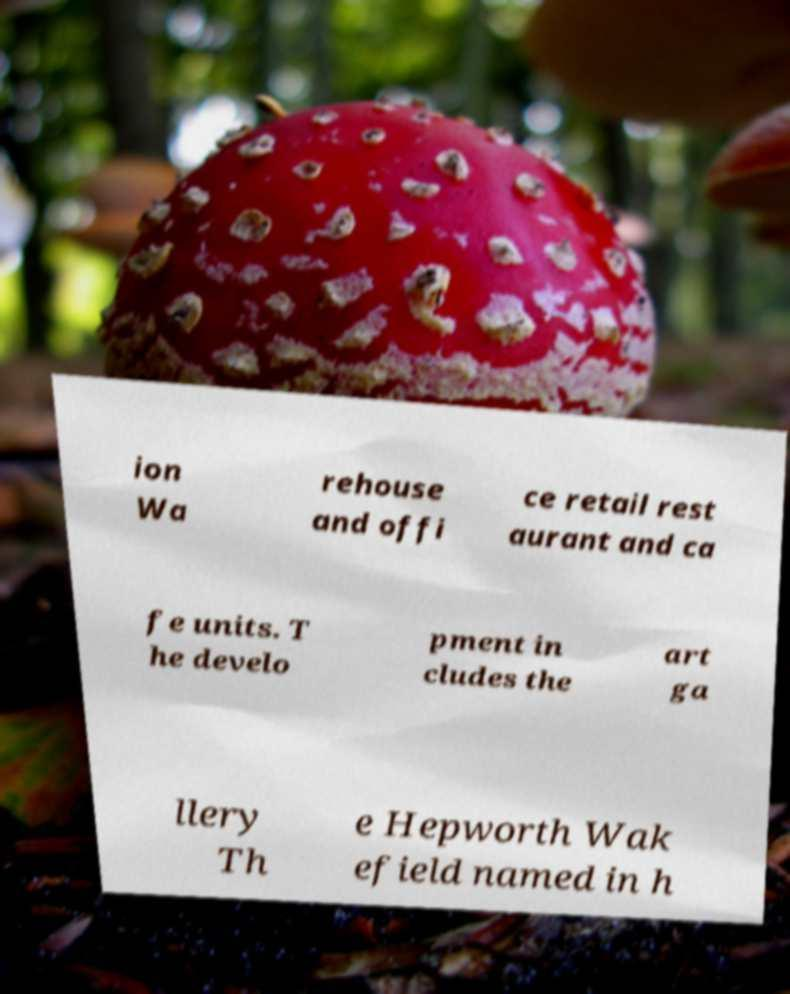Can you read and provide the text displayed in the image?This photo seems to have some interesting text. Can you extract and type it out for me? ion Wa rehouse and offi ce retail rest aurant and ca fe units. T he develo pment in cludes the art ga llery Th e Hepworth Wak efield named in h 